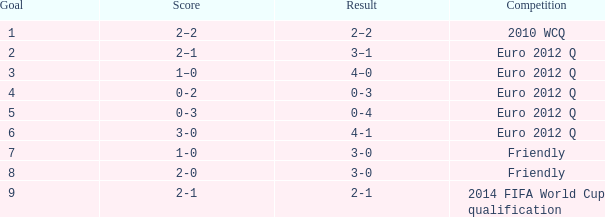What is the result when the score is 0-2? 0-3. 